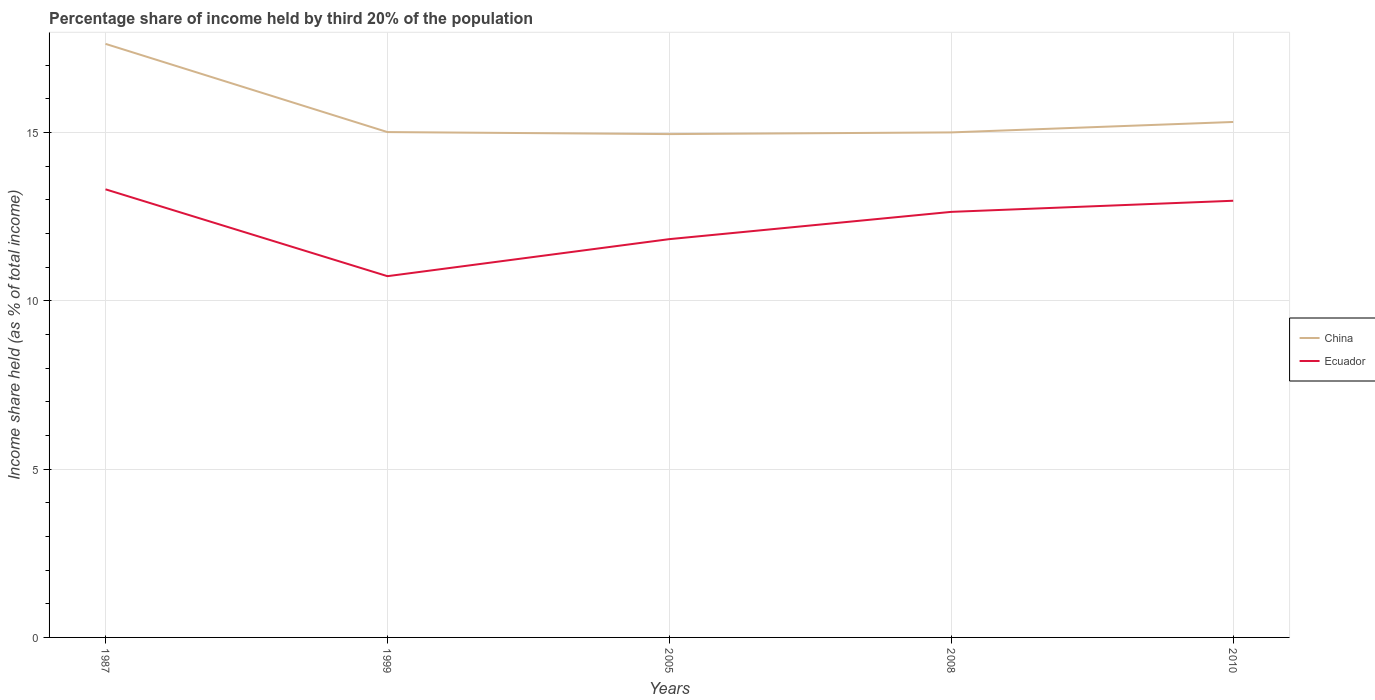How many different coloured lines are there?
Provide a short and direct response. 2. Across all years, what is the maximum share of income held by third 20% of the population in China?
Offer a terse response. 14.95. In which year was the share of income held by third 20% of the population in China maximum?
Your answer should be very brief. 2005. What is the total share of income held by third 20% of the population in China in the graph?
Offer a very short reply. -0.36. What is the difference between the highest and the second highest share of income held by third 20% of the population in Ecuador?
Give a very brief answer. 2.58. What is the difference between the highest and the lowest share of income held by third 20% of the population in Ecuador?
Offer a terse response. 3. How many years are there in the graph?
Offer a very short reply. 5. Are the values on the major ticks of Y-axis written in scientific E-notation?
Your answer should be very brief. No. Where does the legend appear in the graph?
Your response must be concise. Center right. What is the title of the graph?
Offer a terse response. Percentage share of income held by third 20% of the population. What is the label or title of the Y-axis?
Offer a very short reply. Income share held (as % of total income). What is the Income share held (as % of total income) in China in 1987?
Make the answer very short. 17.63. What is the Income share held (as % of total income) in Ecuador in 1987?
Make the answer very short. 13.31. What is the Income share held (as % of total income) of China in 1999?
Provide a short and direct response. 15.01. What is the Income share held (as % of total income) in Ecuador in 1999?
Make the answer very short. 10.73. What is the Income share held (as % of total income) in China in 2005?
Provide a short and direct response. 14.95. What is the Income share held (as % of total income) of Ecuador in 2005?
Ensure brevity in your answer.  11.83. What is the Income share held (as % of total income) in China in 2008?
Give a very brief answer. 15. What is the Income share held (as % of total income) in Ecuador in 2008?
Offer a very short reply. 12.64. What is the Income share held (as % of total income) in China in 2010?
Keep it short and to the point. 15.31. What is the Income share held (as % of total income) in Ecuador in 2010?
Provide a short and direct response. 12.97. Across all years, what is the maximum Income share held (as % of total income) of China?
Provide a succinct answer. 17.63. Across all years, what is the maximum Income share held (as % of total income) in Ecuador?
Make the answer very short. 13.31. Across all years, what is the minimum Income share held (as % of total income) in China?
Ensure brevity in your answer.  14.95. Across all years, what is the minimum Income share held (as % of total income) in Ecuador?
Provide a succinct answer. 10.73. What is the total Income share held (as % of total income) of China in the graph?
Provide a succinct answer. 77.9. What is the total Income share held (as % of total income) in Ecuador in the graph?
Offer a very short reply. 61.48. What is the difference between the Income share held (as % of total income) in China in 1987 and that in 1999?
Provide a succinct answer. 2.62. What is the difference between the Income share held (as % of total income) in Ecuador in 1987 and that in 1999?
Give a very brief answer. 2.58. What is the difference between the Income share held (as % of total income) of China in 1987 and that in 2005?
Give a very brief answer. 2.68. What is the difference between the Income share held (as % of total income) of Ecuador in 1987 and that in 2005?
Your response must be concise. 1.48. What is the difference between the Income share held (as % of total income) of China in 1987 and that in 2008?
Offer a terse response. 2.63. What is the difference between the Income share held (as % of total income) of Ecuador in 1987 and that in 2008?
Provide a short and direct response. 0.67. What is the difference between the Income share held (as % of total income) of China in 1987 and that in 2010?
Give a very brief answer. 2.32. What is the difference between the Income share held (as % of total income) in Ecuador in 1987 and that in 2010?
Give a very brief answer. 0.34. What is the difference between the Income share held (as % of total income) of China in 1999 and that in 2005?
Your response must be concise. 0.06. What is the difference between the Income share held (as % of total income) in Ecuador in 1999 and that in 2005?
Your answer should be compact. -1.1. What is the difference between the Income share held (as % of total income) of Ecuador in 1999 and that in 2008?
Offer a terse response. -1.91. What is the difference between the Income share held (as % of total income) of Ecuador in 1999 and that in 2010?
Provide a succinct answer. -2.24. What is the difference between the Income share held (as % of total income) in China in 2005 and that in 2008?
Your answer should be very brief. -0.05. What is the difference between the Income share held (as % of total income) in Ecuador in 2005 and that in 2008?
Your response must be concise. -0.81. What is the difference between the Income share held (as % of total income) of China in 2005 and that in 2010?
Offer a terse response. -0.36. What is the difference between the Income share held (as % of total income) in Ecuador in 2005 and that in 2010?
Make the answer very short. -1.14. What is the difference between the Income share held (as % of total income) of China in 2008 and that in 2010?
Your answer should be very brief. -0.31. What is the difference between the Income share held (as % of total income) in Ecuador in 2008 and that in 2010?
Ensure brevity in your answer.  -0.33. What is the difference between the Income share held (as % of total income) of China in 1987 and the Income share held (as % of total income) of Ecuador in 2008?
Offer a terse response. 4.99. What is the difference between the Income share held (as % of total income) in China in 1987 and the Income share held (as % of total income) in Ecuador in 2010?
Make the answer very short. 4.66. What is the difference between the Income share held (as % of total income) of China in 1999 and the Income share held (as % of total income) of Ecuador in 2005?
Ensure brevity in your answer.  3.18. What is the difference between the Income share held (as % of total income) of China in 1999 and the Income share held (as % of total income) of Ecuador in 2008?
Keep it short and to the point. 2.37. What is the difference between the Income share held (as % of total income) in China in 1999 and the Income share held (as % of total income) in Ecuador in 2010?
Your answer should be compact. 2.04. What is the difference between the Income share held (as % of total income) of China in 2005 and the Income share held (as % of total income) of Ecuador in 2008?
Offer a terse response. 2.31. What is the difference between the Income share held (as % of total income) in China in 2005 and the Income share held (as % of total income) in Ecuador in 2010?
Offer a very short reply. 1.98. What is the difference between the Income share held (as % of total income) of China in 2008 and the Income share held (as % of total income) of Ecuador in 2010?
Offer a terse response. 2.03. What is the average Income share held (as % of total income) in China per year?
Your response must be concise. 15.58. What is the average Income share held (as % of total income) of Ecuador per year?
Offer a very short reply. 12.3. In the year 1987, what is the difference between the Income share held (as % of total income) in China and Income share held (as % of total income) in Ecuador?
Your answer should be very brief. 4.32. In the year 1999, what is the difference between the Income share held (as % of total income) of China and Income share held (as % of total income) of Ecuador?
Give a very brief answer. 4.28. In the year 2005, what is the difference between the Income share held (as % of total income) of China and Income share held (as % of total income) of Ecuador?
Provide a short and direct response. 3.12. In the year 2008, what is the difference between the Income share held (as % of total income) of China and Income share held (as % of total income) of Ecuador?
Offer a very short reply. 2.36. In the year 2010, what is the difference between the Income share held (as % of total income) of China and Income share held (as % of total income) of Ecuador?
Keep it short and to the point. 2.34. What is the ratio of the Income share held (as % of total income) of China in 1987 to that in 1999?
Your answer should be compact. 1.17. What is the ratio of the Income share held (as % of total income) of Ecuador in 1987 to that in 1999?
Ensure brevity in your answer.  1.24. What is the ratio of the Income share held (as % of total income) in China in 1987 to that in 2005?
Ensure brevity in your answer.  1.18. What is the ratio of the Income share held (as % of total income) of Ecuador in 1987 to that in 2005?
Provide a short and direct response. 1.13. What is the ratio of the Income share held (as % of total income) in China in 1987 to that in 2008?
Make the answer very short. 1.18. What is the ratio of the Income share held (as % of total income) of Ecuador in 1987 to that in 2008?
Provide a succinct answer. 1.05. What is the ratio of the Income share held (as % of total income) of China in 1987 to that in 2010?
Your answer should be very brief. 1.15. What is the ratio of the Income share held (as % of total income) in Ecuador in 1987 to that in 2010?
Make the answer very short. 1.03. What is the ratio of the Income share held (as % of total income) in China in 1999 to that in 2005?
Provide a short and direct response. 1. What is the ratio of the Income share held (as % of total income) of Ecuador in 1999 to that in 2005?
Provide a short and direct response. 0.91. What is the ratio of the Income share held (as % of total income) of China in 1999 to that in 2008?
Make the answer very short. 1. What is the ratio of the Income share held (as % of total income) of Ecuador in 1999 to that in 2008?
Your answer should be compact. 0.85. What is the ratio of the Income share held (as % of total income) in China in 1999 to that in 2010?
Give a very brief answer. 0.98. What is the ratio of the Income share held (as % of total income) in Ecuador in 1999 to that in 2010?
Your answer should be very brief. 0.83. What is the ratio of the Income share held (as % of total income) in China in 2005 to that in 2008?
Give a very brief answer. 1. What is the ratio of the Income share held (as % of total income) of Ecuador in 2005 to that in 2008?
Provide a short and direct response. 0.94. What is the ratio of the Income share held (as % of total income) in China in 2005 to that in 2010?
Ensure brevity in your answer.  0.98. What is the ratio of the Income share held (as % of total income) in Ecuador in 2005 to that in 2010?
Your answer should be compact. 0.91. What is the ratio of the Income share held (as % of total income) of China in 2008 to that in 2010?
Ensure brevity in your answer.  0.98. What is the ratio of the Income share held (as % of total income) in Ecuador in 2008 to that in 2010?
Your answer should be very brief. 0.97. What is the difference between the highest and the second highest Income share held (as % of total income) of China?
Offer a very short reply. 2.32. What is the difference between the highest and the second highest Income share held (as % of total income) in Ecuador?
Ensure brevity in your answer.  0.34. What is the difference between the highest and the lowest Income share held (as % of total income) in China?
Your answer should be very brief. 2.68. What is the difference between the highest and the lowest Income share held (as % of total income) in Ecuador?
Provide a short and direct response. 2.58. 